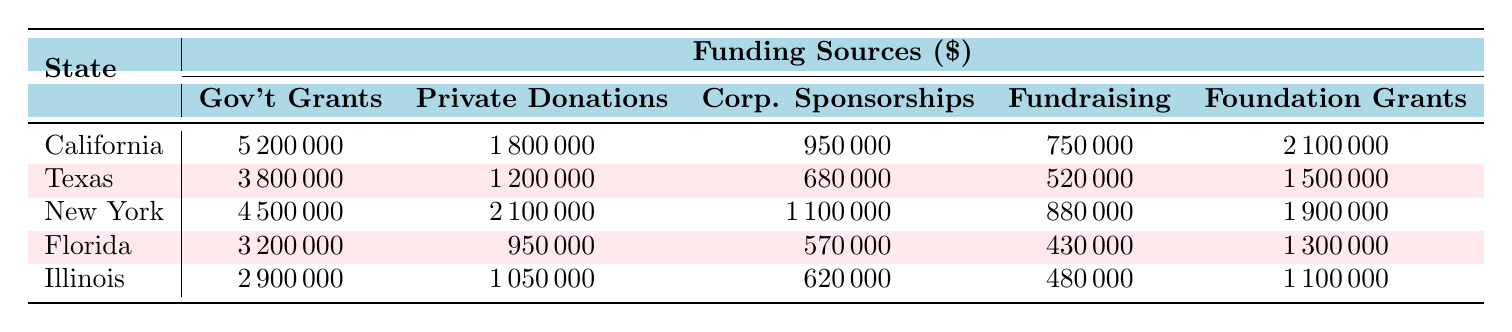What is the total amount of Government Grants for all states? To find the total amount of Government Grants, sum the values for each state: 5200000 (California) + 3800000 (Texas) + 4500000 (New York) + 3200000 (Florida) + 2900000 (Illinois) = 19600000.
Answer: 19600000 Which state has the highest amount of Private Donations? Looking at the Private Donations column, California has 1800000, Texas has 1200000, New York has 2100000, Florida has 950000, and Illinois has 1050000. The highest is 2100000 from New York.
Answer: New York What is the difference between the total Corporate Sponsorships in California and Texas? Corporate Sponsorships for California is 950000 and for Texas is 680000. The difference is 950000 - 680000 = 270000.
Answer: 270000 What is the average amount of Foundation Grants across all states? Foundation Grants values are: 2100000 (California), 1500000 (Texas), 1900000 (New York), 1300000 (Florida), and 1100000 (Illinois). The total is 2100000 + 1500000 + 1900000 + 1300000 + 1100000 = 10000000. There are 5 states, so the average is 10000000 / 5 = 2000000.
Answer: 2000000 Is the amount of Fundraising Events in Texas greater than in Florida? Fundraising Events for Texas is 520000 and for Florida it is 430000. Since 520000 is greater than 430000, the statement is true.
Answer: Yes Which state received the least amount in Corporate Sponsorships? The Corporate Sponsorships amounts are: 950000 (California), 680000 (Texas), 1100000 (New York), 570000 (Florida), and 620000 (Illinois). The least amount is 570000 from Florida.
Answer: Florida What state has the highest total funding? Calculate the total funding for each state: California: 5200000 + 1800000 + 950000 + 750000 + 2100000 = 10750000, Texas: 3800000 + 1200000 + 680000 + 520000 + 1500000 = 7800000, New York: 4500000 + 2100000 + 1100000 + 880000 + 1900000 = 10600000, Florida: 3200000 + 950000 + 570000 + 430000 + 1300000 = 7380000, Illinois: 2900000 + 1050000 + 620000 + 480000 + 1100000 = 6150000. The highest total is from California at 10750000.
Answer: California What is the total funding amount for all states combined? Sum the total funding for each state: 10750000 (California) + 7800000 (Texas) + 10600000 (New York) + 7380000 (Florida) + 6150000 (Illinois) = 50010000.
Answer: 50010000 Which funding source contributes the least to Illinois? The amounts for Illinois are: Government Grants 2900000, Private Donations 1050000, Corporate Sponsorships 620000, Fundraising Events 480000, and Foundation Grants 1100000. The least amount is 480000 from Fundraising Events.
Answer: Fundraising Events How much more does New York receive in Private Donations compared to Florida? Private Donations for New York is 2100000 and for Florida it is 950000. The difference is 2100000 - 950000 = 1150000.
Answer: 1150000 